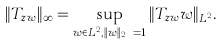Convert formula to latex. <formula><loc_0><loc_0><loc_500><loc_500>\| T _ { z w } \| _ { \infty } = \sup _ { w \in L ^ { 2 } , \| w \| _ { L ^ { 2 } } = 1 } \| T _ { z w } w \| _ { L ^ { 2 } } .</formula> 